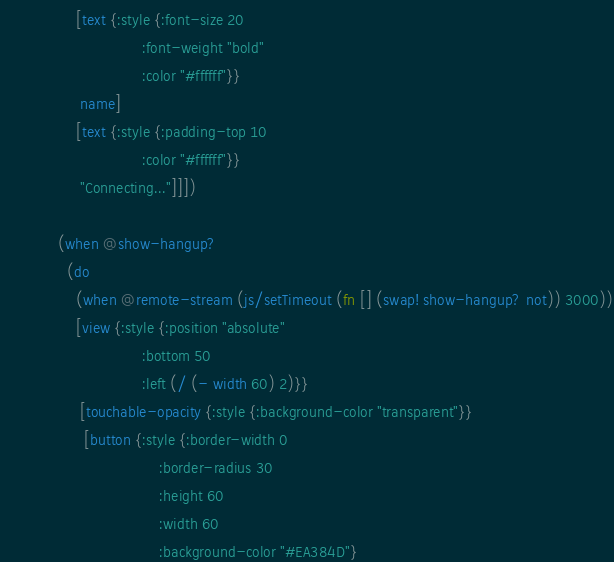<code> <loc_0><loc_0><loc_500><loc_500><_Clojure_>                 [text {:style {:font-size 20
                                :font-weight "bold"
                                :color "#ffffff"}}
                  name]
                 [text {:style {:padding-top 10
                                :color "#ffffff"}}
                  "Connecting..."]]])

             (when @show-hangup?
               (do
                 (when @remote-stream (js/setTimeout (fn [] (swap! show-hangup? not)) 3000))
                 [view {:style {:position "absolute"
                                :bottom 50
                                :left (/ (- width 60) 2)}}
                  [touchable-opacity {:style {:background-color "transparent"}}
                   [button {:style {:border-width 0
                                    :border-radius 30
                                    :height 60
                                    :width 60
                                    :background-color "#EA384D"}</code> 